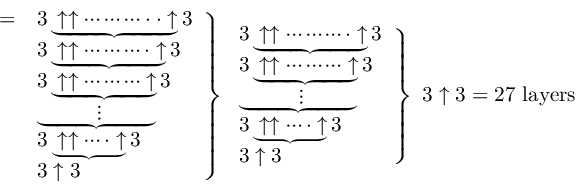Convert formula to latex. <formula><loc_0><loc_0><loc_500><loc_500>{ \begin{array} { l l } { = } & { 3 \underbrace { \uparrow \uparrow \cdots \cdots \cdots \cdot \cdot \uparrow } 3 } \\ & { 3 \underbrace { \uparrow \uparrow \cdots \cdots \cdots \cdot \uparrow } 3 } \\ & { 3 \underbrace { \uparrow \uparrow \cdots \cdots \cdots \uparrow } 3 } \\ & { \underbrace { \quad \, \vdots \quad \, } } \\ & { 3 \underbrace { \uparrow \uparrow \cdots \cdot \uparrow } 3 } \\ & { 3 \uparrow 3 } \end{array} } \right \} { \begin{array} { l } { 3 \underbrace { \uparrow \uparrow \cdots \cdots \cdots \cdot \uparrow } 3 } \\ { 3 \underbrace { \uparrow \uparrow \cdots \cdots \cdots \uparrow } 3 } \\ { \underbrace { \quad \, \vdots \quad \, } } \\ { 3 \underbrace { \uparrow \uparrow \cdots \cdot \uparrow } 3 } \\ { 3 \uparrow 3 } \end{array} } \right \} \ 3 \uparrow 3 = { 2 7 l a y e r s }</formula> 